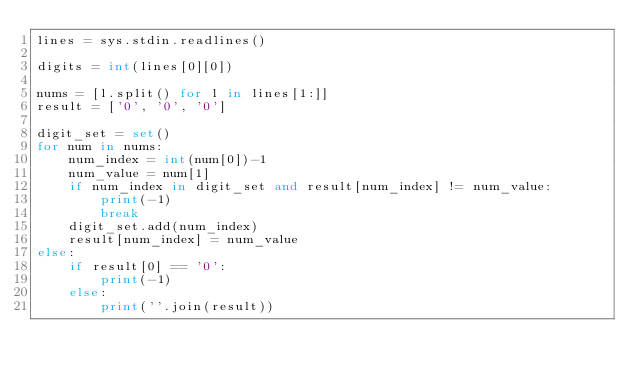<code> <loc_0><loc_0><loc_500><loc_500><_Python_>lines = sys.stdin.readlines()

digits = int(lines[0][0])

nums = [l.split() for l in lines[1:]]
result = ['0', '0', '0']

digit_set = set()
for num in nums:
    num_index = int(num[0])-1
    num_value = num[1]
    if num_index in digit_set and result[num_index] != num_value:
        print(-1)
        break
    digit_set.add(num_index)
    result[num_index] = num_value
else:
    if result[0] == '0':
        print(-1)
    else:
        print(''.join(result))</code> 